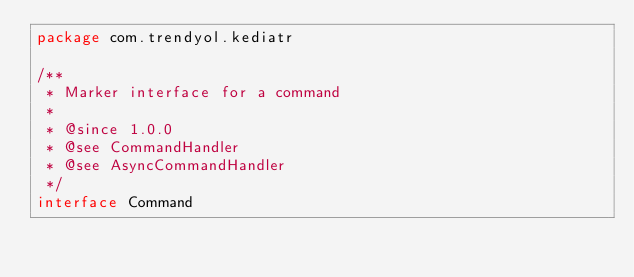<code> <loc_0><loc_0><loc_500><loc_500><_Kotlin_>package com.trendyol.kediatr

/**
 * Marker interface for a command
 *
 * @since 1.0.0
 * @see CommandHandler
 * @see AsyncCommandHandler
 */
interface Command
</code> 